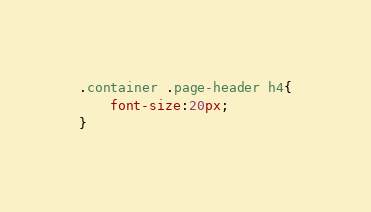<code> <loc_0><loc_0><loc_500><loc_500><_CSS_>
.container .page-header h4{
    font-size:20px;
}</code> 